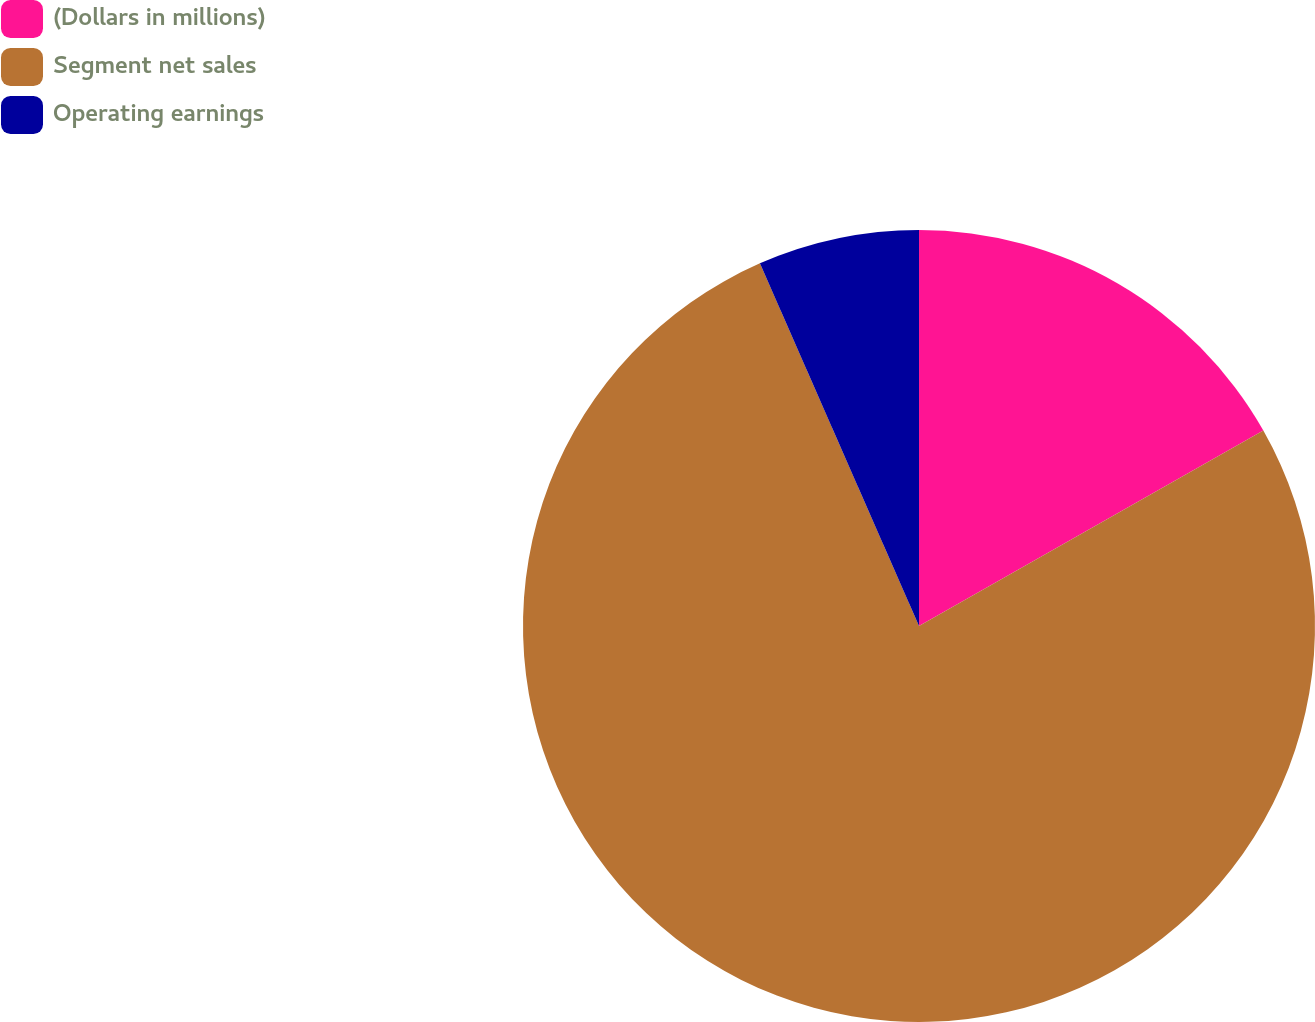Convert chart. <chart><loc_0><loc_0><loc_500><loc_500><pie_chart><fcel>(Dollars in millions)<fcel>Segment net sales<fcel>Operating earnings<nl><fcel>16.78%<fcel>76.64%<fcel>6.58%<nl></chart> 